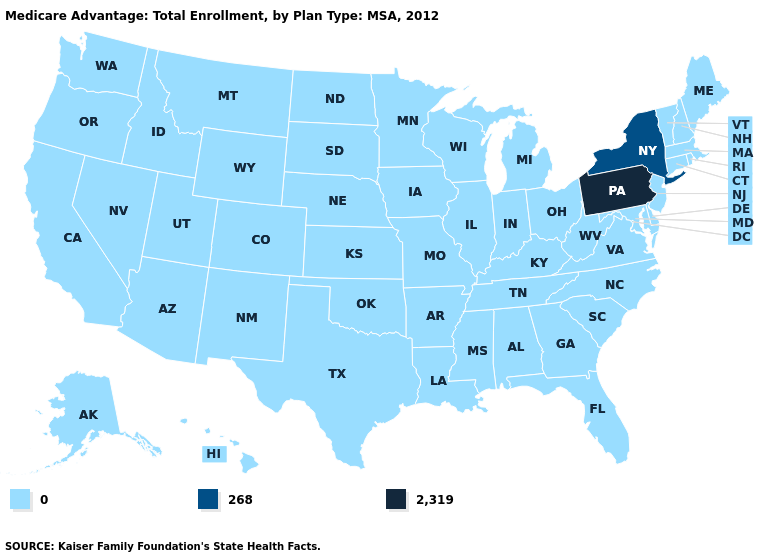How many symbols are there in the legend?
Concise answer only. 3. What is the highest value in the Northeast ?
Write a very short answer. 2,319. What is the value of California?
Be succinct. 0. What is the value of Alaska?
Keep it brief. 0. Does Pennsylvania have the lowest value in the USA?
Be succinct. No. Name the states that have a value in the range 268?
Be succinct. New York. What is the value of North Dakota?
Give a very brief answer. 0. Name the states that have a value in the range 2,319?
Write a very short answer. Pennsylvania. What is the highest value in the USA?
Give a very brief answer. 2,319. What is the lowest value in the Northeast?
Answer briefly. 0. What is the value of Vermont?
Answer briefly. 0. Which states have the lowest value in the Northeast?
Give a very brief answer. Connecticut, Massachusetts, Maine, New Hampshire, New Jersey, Rhode Island, Vermont. Which states have the lowest value in the USA?
Give a very brief answer. Alaska, Alabama, Arkansas, Arizona, California, Colorado, Connecticut, Delaware, Florida, Georgia, Hawaii, Iowa, Idaho, Illinois, Indiana, Kansas, Kentucky, Louisiana, Massachusetts, Maryland, Maine, Michigan, Minnesota, Missouri, Mississippi, Montana, North Carolina, North Dakota, Nebraska, New Hampshire, New Jersey, New Mexico, Nevada, Ohio, Oklahoma, Oregon, Rhode Island, South Carolina, South Dakota, Tennessee, Texas, Utah, Virginia, Vermont, Washington, Wisconsin, West Virginia, Wyoming. 